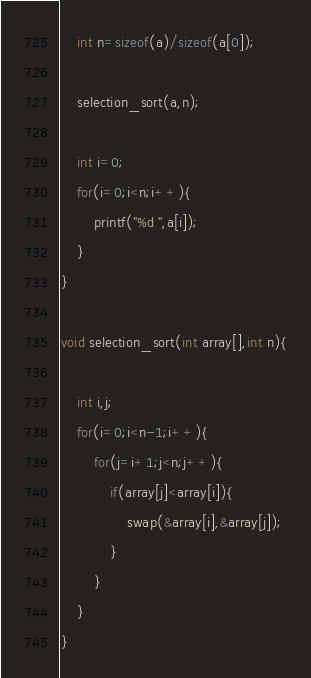<code> <loc_0><loc_0><loc_500><loc_500><_C_>	int n=sizeof(a)/sizeof(a[0]);
	
	selection_sort(a,n);
	
	int i=0;
	for(i=0;i<n;i++){
		printf("%d ",a[i]);
	}
}

void selection_sort(int array[],int n){
	
	int i,j;
	for(i=0;i<n-1;i++){
		for(j=i+1;j<n;j++){
			if(array[j]<array[i]){
				swap(&array[i],&array[j]);
			}
		}
	}
}
</code> 